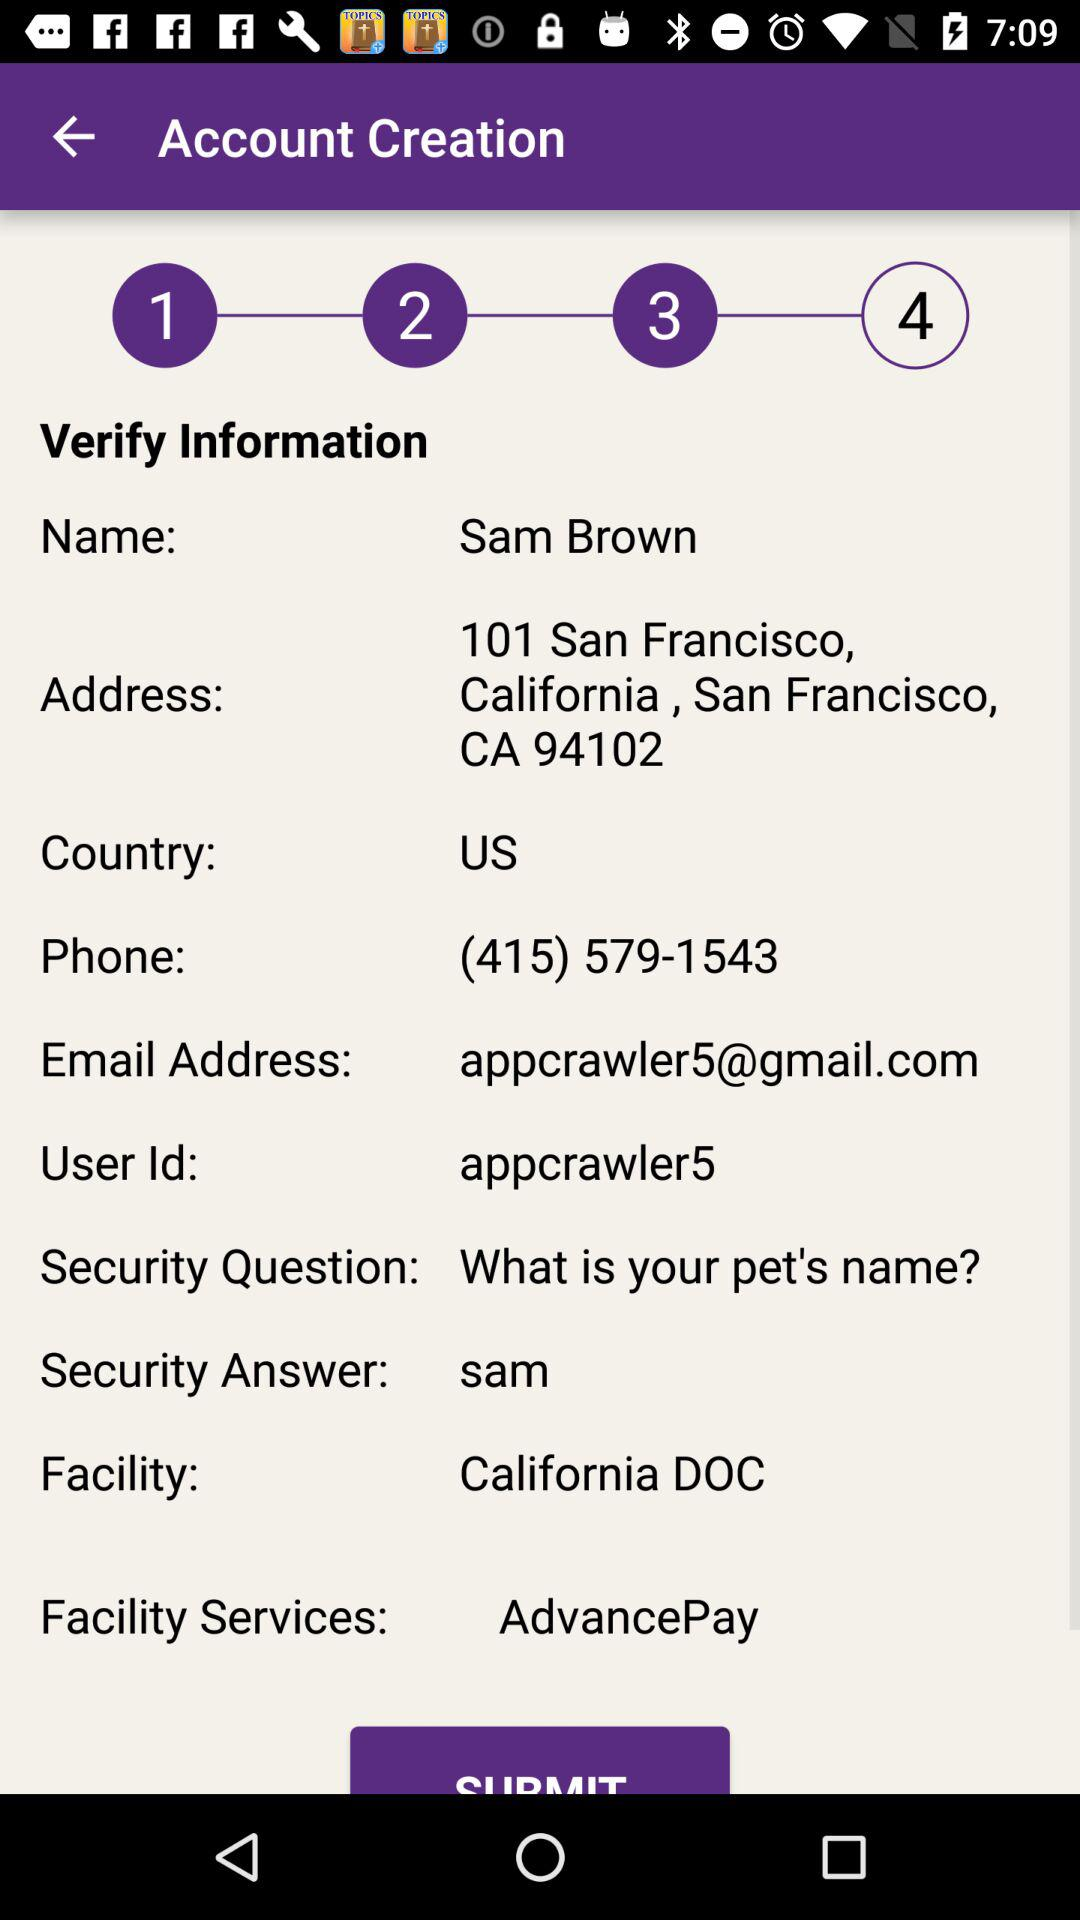What country is mentioned? The mentioned country is the United States. 